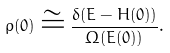Convert formula to latex. <formula><loc_0><loc_0><loc_500><loc_500>\rho ( 0 ) \cong \frac { \delta ( E - H ( 0 ) ) } { \Omega ( E ( 0 ) ) } .</formula> 